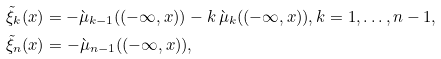Convert formula to latex. <formula><loc_0><loc_0><loc_500><loc_500>& \tilde { \xi } _ { k } ( x ) = - \grave { \mu } _ { k - 1 } ( ( - \infty , x ) ) - k \, \grave { \mu } _ { k } ( ( - \infty , x ) ) , k = 1 , \dots , n - 1 , \\ & \tilde { \xi } _ { n } ( x ) = - \grave { \mu } _ { n - 1 } ( ( - \infty , x ) ) ,</formula> 